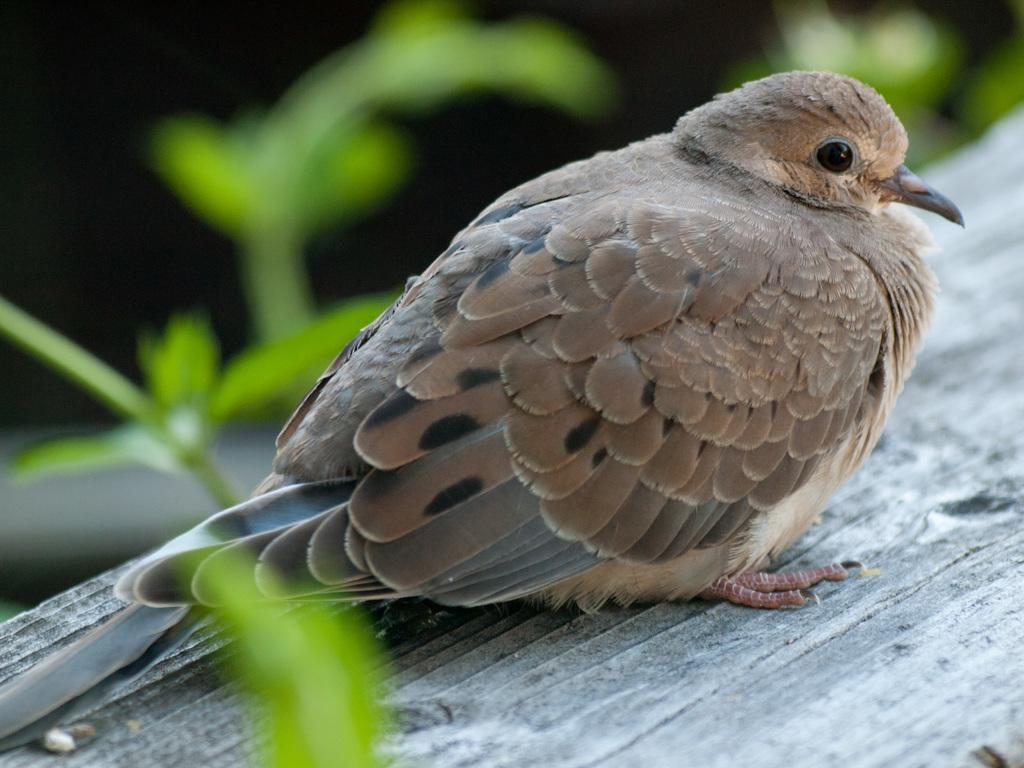What type of animal can be seen in the image? There is a bird in the image. Where is the bird located? The bird is on a wooden plank. In which direction is the bird facing? The bird is facing towards the right side. What can be seen on the left side of the image? Few leaves are visible on the left side of the image. What type of stocking is the bird wearing on its legs in the image? There is no stocking present on the bird's legs in the image. How many nuts can be seen in the image? There are no nuts visible in the image. 